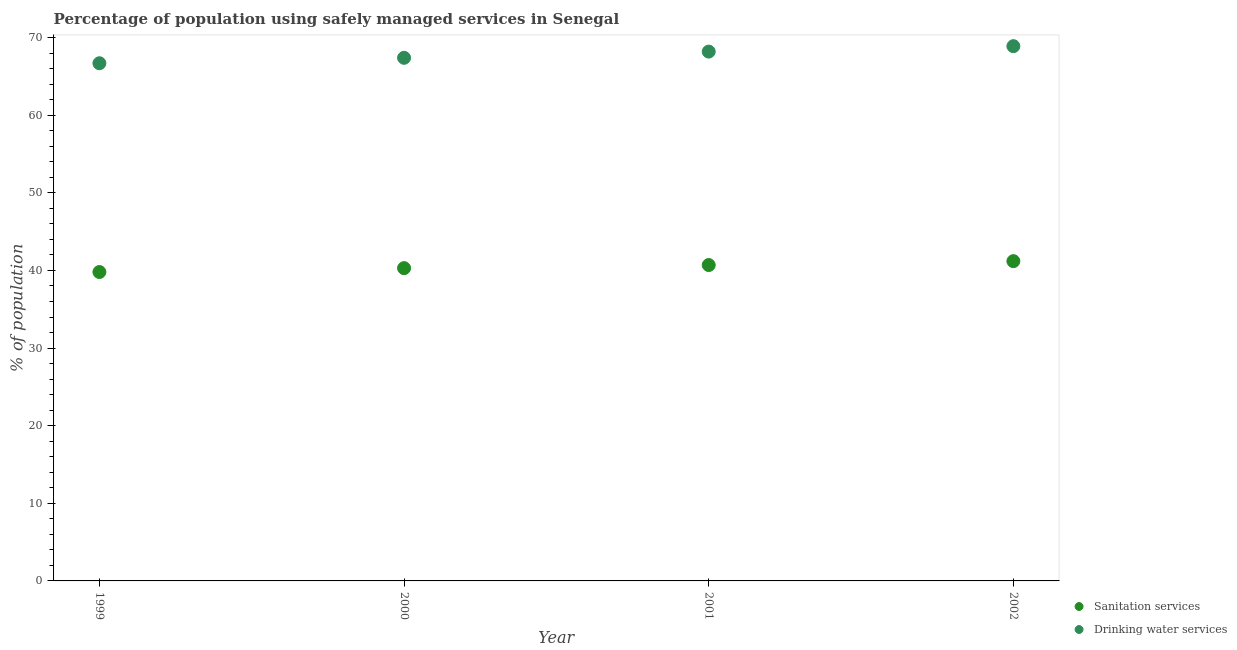Is the number of dotlines equal to the number of legend labels?
Your answer should be very brief. Yes. What is the percentage of population who used sanitation services in 2000?
Offer a very short reply. 40.3. Across all years, what is the maximum percentage of population who used drinking water services?
Keep it short and to the point. 68.9. Across all years, what is the minimum percentage of population who used sanitation services?
Provide a succinct answer. 39.8. In which year was the percentage of population who used sanitation services maximum?
Your answer should be compact. 2002. In which year was the percentage of population who used sanitation services minimum?
Your answer should be very brief. 1999. What is the total percentage of population who used drinking water services in the graph?
Make the answer very short. 271.2. What is the difference between the percentage of population who used drinking water services in 1999 and that in 2002?
Your answer should be compact. -2.2. What is the difference between the percentage of population who used drinking water services in 1999 and the percentage of population who used sanitation services in 2000?
Offer a very short reply. 26.4. What is the average percentage of population who used drinking water services per year?
Your answer should be compact. 67.8. In the year 2000, what is the difference between the percentage of population who used drinking water services and percentage of population who used sanitation services?
Offer a terse response. 27.1. What is the ratio of the percentage of population who used sanitation services in 2000 to that in 2002?
Provide a succinct answer. 0.98. Is the difference between the percentage of population who used drinking water services in 2000 and 2001 greater than the difference between the percentage of population who used sanitation services in 2000 and 2001?
Your response must be concise. No. What is the difference between the highest and the second highest percentage of population who used drinking water services?
Provide a succinct answer. 0.7. What is the difference between the highest and the lowest percentage of population who used drinking water services?
Give a very brief answer. 2.2. In how many years, is the percentage of population who used sanitation services greater than the average percentage of population who used sanitation services taken over all years?
Keep it short and to the point. 2. Is the percentage of population who used sanitation services strictly less than the percentage of population who used drinking water services over the years?
Ensure brevity in your answer.  Yes. How many dotlines are there?
Provide a succinct answer. 2. Where does the legend appear in the graph?
Give a very brief answer. Bottom right. How are the legend labels stacked?
Ensure brevity in your answer.  Vertical. What is the title of the graph?
Keep it short and to the point. Percentage of population using safely managed services in Senegal. What is the label or title of the Y-axis?
Make the answer very short. % of population. What is the % of population of Sanitation services in 1999?
Your answer should be very brief. 39.8. What is the % of population in Drinking water services in 1999?
Your answer should be very brief. 66.7. What is the % of population in Sanitation services in 2000?
Offer a terse response. 40.3. What is the % of population in Drinking water services in 2000?
Make the answer very short. 67.4. What is the % of population of Sanitation services in 2001?
Your answer should be very brief. 40.7. What is the % of population of Drinking water services in 2001?
Your answer should be compact. 68.2. What is the % of population of Sanitation services in 2002?
Your response must be concise. 41.2. What is the % of population in Drinking water services in 2002?
Your response must be concise. 68.9. Across all years, what is the maximum % of population in Sanitation services?
Make the answer very short. 41.2. Across all years, what is the maximum % of population of Drinking water services?
Make the answer very short. 68.9. Across all years, what is the minimum % of population of Sanitation services?
Your answer should be compact. 39.8. Across all years, what is the minimum % of population of Drinking water services?
Your answer should be compact. 66.7. What is the total % of population in Sanitation services in the graph?
Make the answer very short. 162. What is the total % of population in Drinking water services in the graph?
Ensure brevity in your answer.  271.2. What is the difference between the % of population of Drinking water services in 1999 and that in 2000?
Your answer should be compact. -0.7. What is the difference between the % of population in Sanitation services in 1999 and that in 2001?
Make the answer very short. -0.9. What is the difference between the % of population in Drinking water services in 1999 and that in 2002?
Offer a terse response. -2.2. What is the difference between the % of population of Drinking water services in 2000 and that in 2001?
Provide a short and direct response. -0.8. What is the difference between the % of population in Drinking water services in 2000 and that in 2002?
Offer a terse response. -1.5. What is the difference between the % of population of Sanitation services in 2001 and that in 2002?
Offer a terse response. -0.5. What is the difference between the % of population of Drinking water services in 2001 and that in 2002?
Your answer should be very brief. -0.7. What is the difference between the % of population of Sanitation services in 1999 and the % of population of Drinking water services in 2000?
Keep it short and to the point. -27.6. What is the difference between the % of population of Sanitation services in 1999 and the % of population of Drinking water services in 2001?
Offer a very short reply. -28.4. What is the difference between the % of population of Sanitation services in 1999 and the % of population of Drinking water services in 2002?
Offer a very short reply. -29.1. What is the difference between the % of population in Sanitation services in 2000 and the % of population in Drinking water services in 2001?
Ensure brevity in your answer.  -27.9. What is the difference between the % of population of Sanitation services in 2000 and the % of population of Drinking water services in 2002?
Ensure brevity in your answer.  -28.6. What is the difference between the % of population of Sanitation services in 2001 and the % of population of Drinking water services in 2002?
Your answer should be very brief. -28.2. What is the average % of population of Sanitation services per year?
Offer a terse response. 40.5. What is the average % of population of Drinking water services per year?
Ensure brevity in your answer.  67.8. In the year 1999, what is the difference between the % of population in Sanitation services and % of population in Drinking water services?
Offer a very short reply. -26.9. In the year 2000, what is the difference between the % of population in Sanitation services and % of population in Drinking water services?
Provide a succinct answer. -27.1. In the year 2001, what is the difference between the % of population in Sanitation services and % of population in Drinking water services?
Your answer should be compact. -27.5. In the year 2002, what is the difference between the % of population of Sanitation services and % of population of Drinking water services?
Provide a succinct answer. -27.7. What is the ratio of the % of population of Sanitation services in 1999 to that in 2000?
Keep it short and to the point. 0.99. What is the ratio of the % of population of Drinking water services in 1999 to that in 2000?
Make the answer very short. 0.99. What is the ratio of the % of population of Sanitation services in 1999 to that in 2001?
Provide a short and direct response. 0.98. What is the ratio of the % of population of Sanitation services in 1999 to that in 2002?
Ensure brevity in your answer.  0.97. What is the ratio of the % of population in Drinking water services in 1999 to that in 2002?
Offer a very short reply. 0.97. What is the ratio of the % of population in Sanitation services in 2000 to that in 2001?
Make the answer very short. 0.99. What is the ratio of the % of population of Drinking water services in 2000 to that in 2001?
Offer a very short reply. 0.99. What is the ratio of the % of population in Sanitation services in 2000 to that in 2002?
Ensure brevity in your answer.  0.98. What is the ratio of the % of population in Drinking water services in 2000 to that in 2002?
Keep it short and to the point. 0.98. What is the ratio of the % of population in Sanitation services in 2001 to that in 2002?
Your answer should be very brief. 0.99. What is the ratio of the % of population in Drinking water services in 2001 to that in 2002?
Give a very brief answer. 0.99. What is the difference between the highest and the second highest % of population in Drinking water services?
Your answer should be compact. 0.7. What is the difference between the highest and the lowest % of population of Drinking water services?
Offer a terse response. 2.2. 